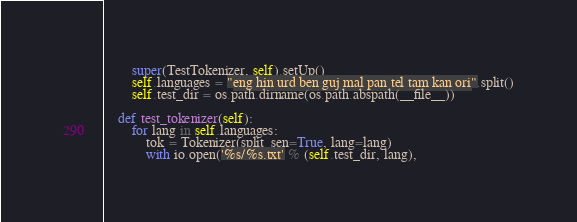<code> <loc_0><loc_0><loc_500><loc_500><_Python_>        super(TestTokenizer, self).setUp()
        self.languages = "eng hin urd ben guj mal pan tel tam kan ori".split()
        self.test_dir = os.path.dirname(os.path.abspath(__file__))

    def test_tokenizer(self):
        for lang in self.languages:
            tok = Tokenizer(split_sen=True, lang=lang)
            with io.open('%s/%s.txt' % (self.test_dir, lang),</code> 